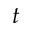Convert formula to latex. <formula><loc_0><loc_0><loc_500><loc_500>t</formula> 